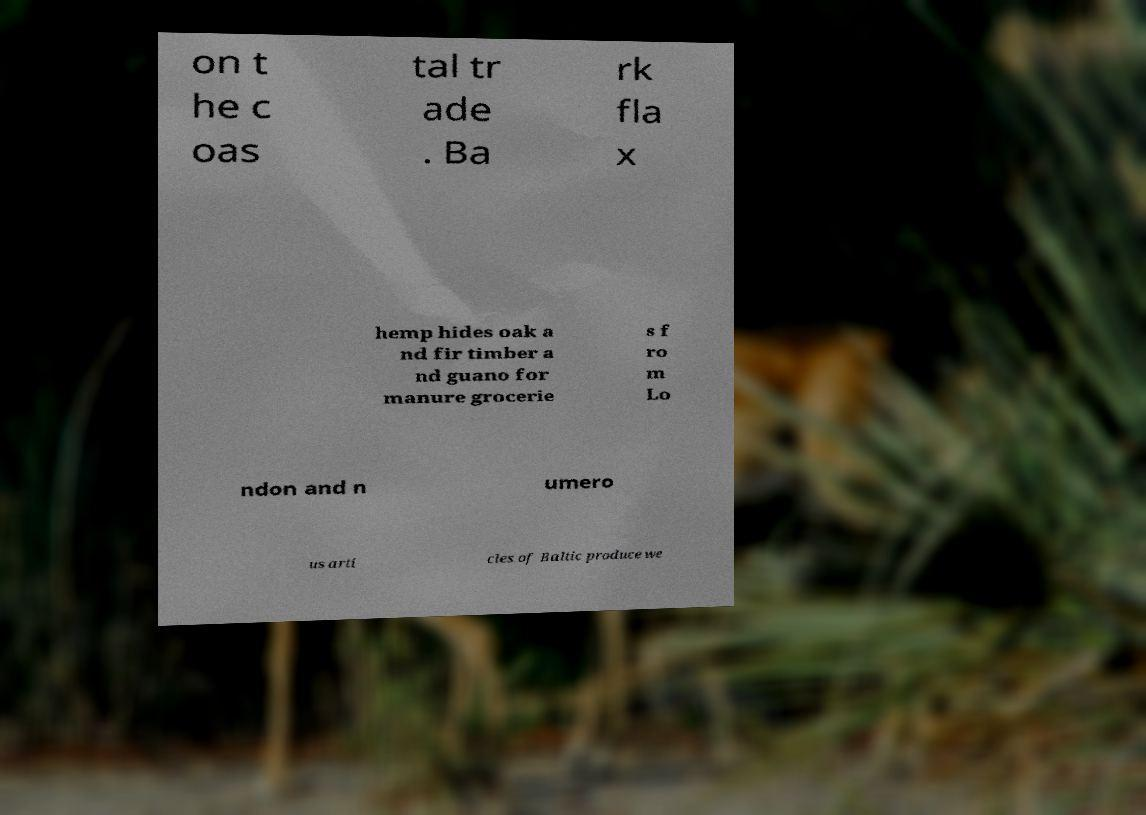Can you accurately transcribe the text from the provided image for me? on t he c oas tal tr ade . Ba rk fla x hemp hides oak a nd fir timber a nd guano for manure grocerie s f ro m Lo ndon and n umero us arti cles of Baltic produce we 